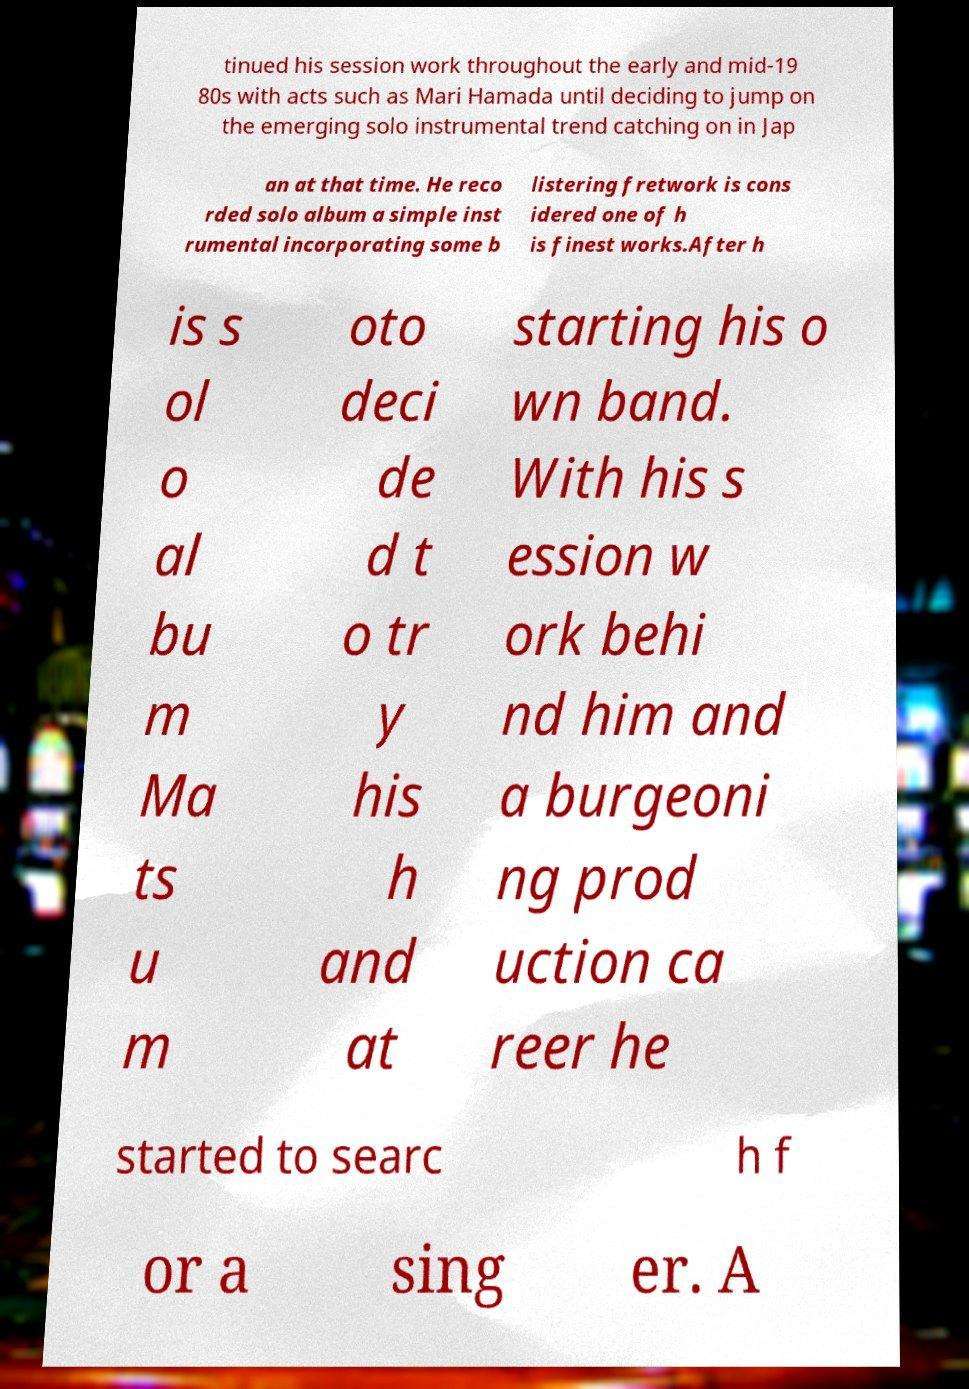There's text embedded in this image that I need extracted. Can you transcribe it verbatim? tinued his session work throughout the early and mid-19 80s with acts such as Mari Hamada until deciding to jump on the emerging solo instrumental trend catching on in Jap an at that time. He reco rded solo album a simple inst rumental incorporating some b listering fretwork is cons idered one of h is finest works.After h is s ol o al bu m Ma ts u m oto deci de d t o tr y his h and at starting his o wn band. With his s ession w ork behi nd him and a burgeoni ng prod uction ca reer he started to searc h f or a sing er. A 